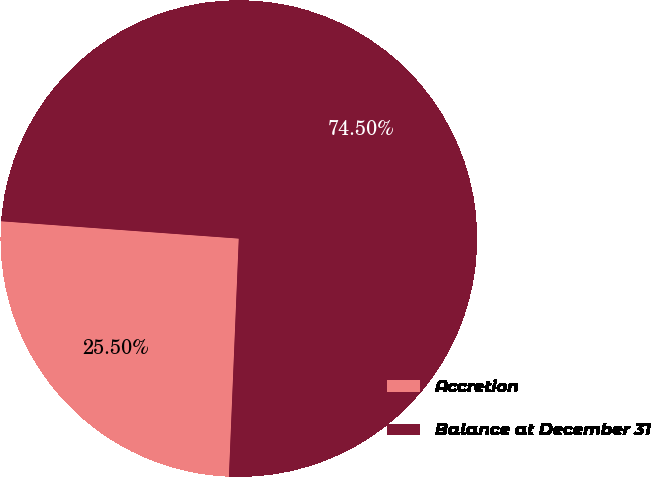Convert chart. <chart><loc_0><loc_0><loc_500><loc_500><pie_chart><fcel>Accretion<fcel>Balance at December 31<nl><fcel>25.5%<fcel>74.5%<nl></chart> 